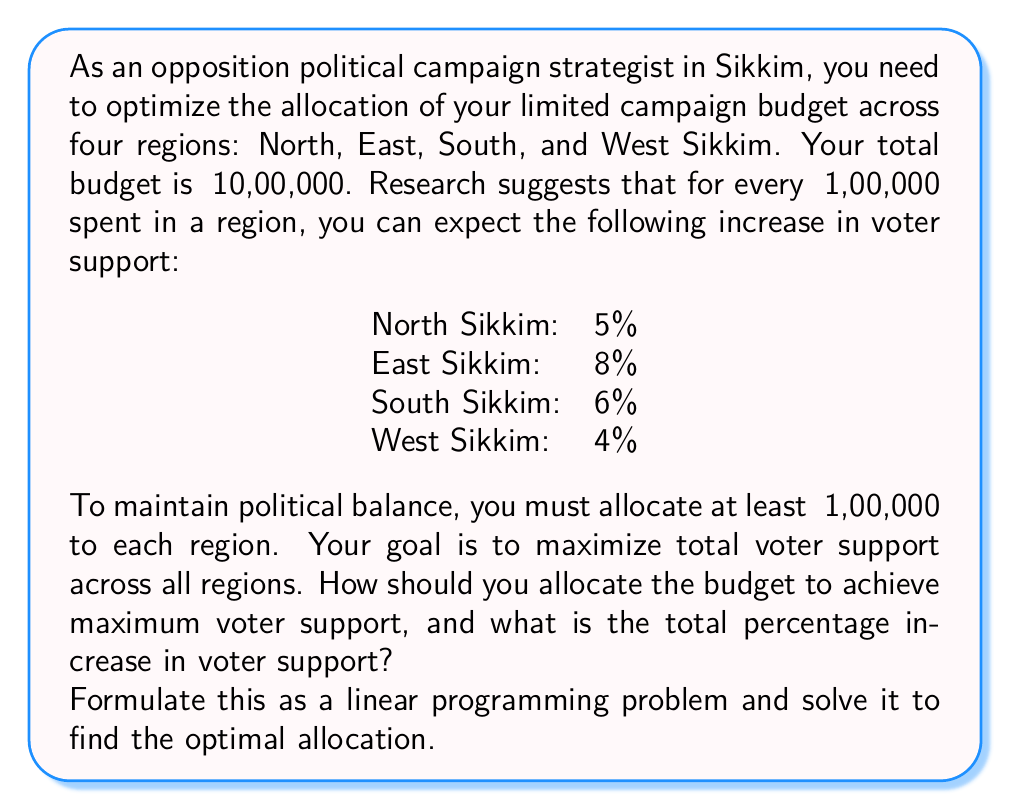Solve this math problem. Let's approach this step-by-step:

1) First, we need to define our variables:
   Let $x_1, x_2, x_3, x_4$ represent the amount (in lakhs) allocated to North, East, South, and West Sikkim respectively.

2) Our objective function is to maximize total voter support:
   $$\text{Maximize } Z = 5x_1 + 8x_2 + 6x_3 + 4x_4$$

3) Our constraints are:
   a) Total budget: $x_1 + x_2 + x_3 + x_4 = 10$ (since budget is ₹10,00,000 or 10 lakhs)
   b) Minimum allocation: $x_1, x_2, x_3, x_4 \geq 1$ (at least ₹1,00,000 for each region)

4) This is a linear programming problem. We can solve it using the simplex method or graphically. Given the simplicity, let's solve it logically:

   - We must allocate at least 1 lakh to each region, so 4 lakhs are pre-allocated.
   - We have 6 lakhs left to allocate optimally.
   - East Sikkim gives the highest return (8% per lakh), so we should allocate as much as possible there.
   - After East, South Sikkim gives the next highest return.

5) Therefore, the optimal allocation is:
   East Sikkim: 1 + 6 = 7 lakhs
   South Sikkim: 1 lakh
   North Sikkim: 1 lakh
   West Sikkim: 1 lakh

6) To calculate the total percentage increase in voter support:
   $$(7 \times 8\%) + (1 \times 6\%) + (1 \times 5\%) + (1 \times 4\%) = 56\% + 6\% + 5\% + 4\% = 71\%$$
Answer: Optimal budget allocation:
East Sikkim: ₹7,00,000
South Sikkim: ₹1,00,000
North Sikkim: ₹1,00,000
West Sikkim: ₹1,00,000

Total percentage increase in voter support: 71% 